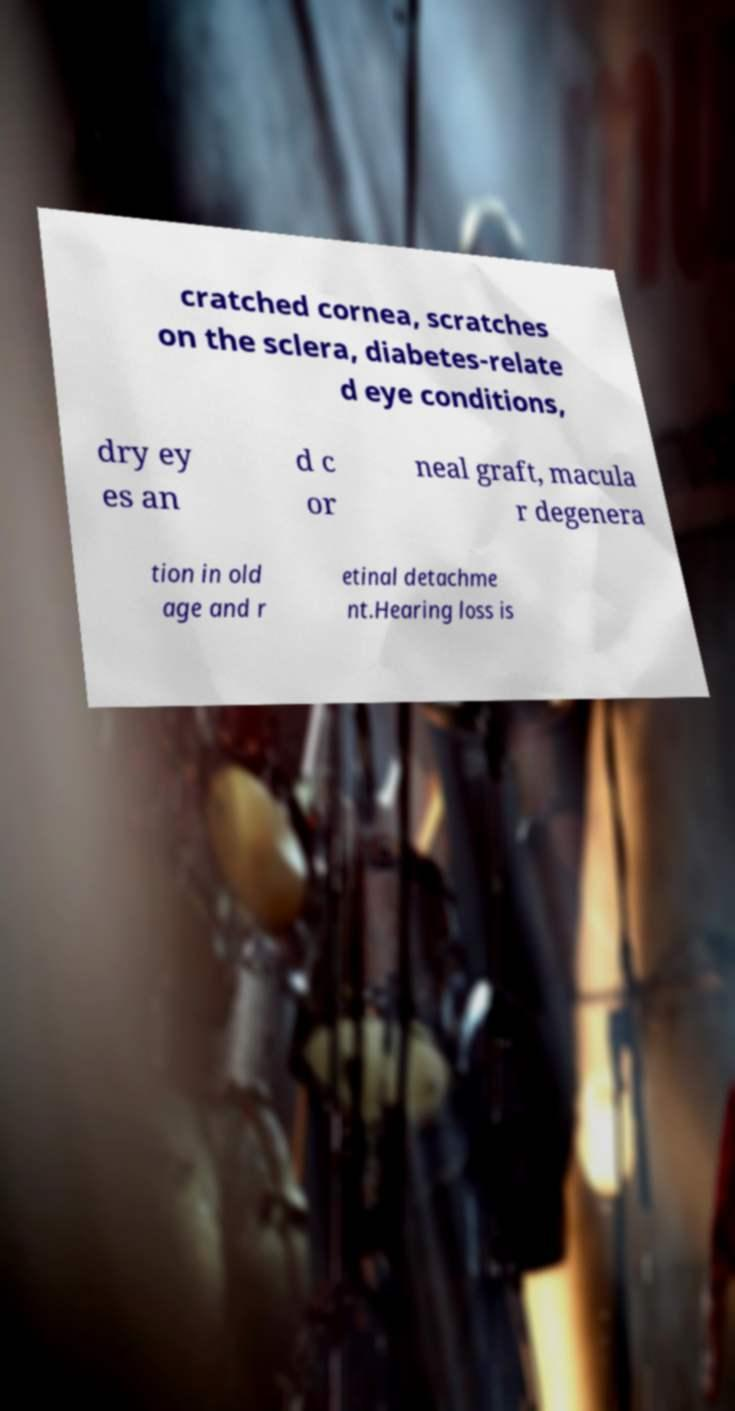What messages or text are displayed in this image? I need them in a readable, typed format. cratched cornea, scratches on the sclera, diabetes-relate d eye conditions, dry ey es an d c or neal graft, macula r degenera tion in old age and r etinal detachme nt.Hearing loss is 